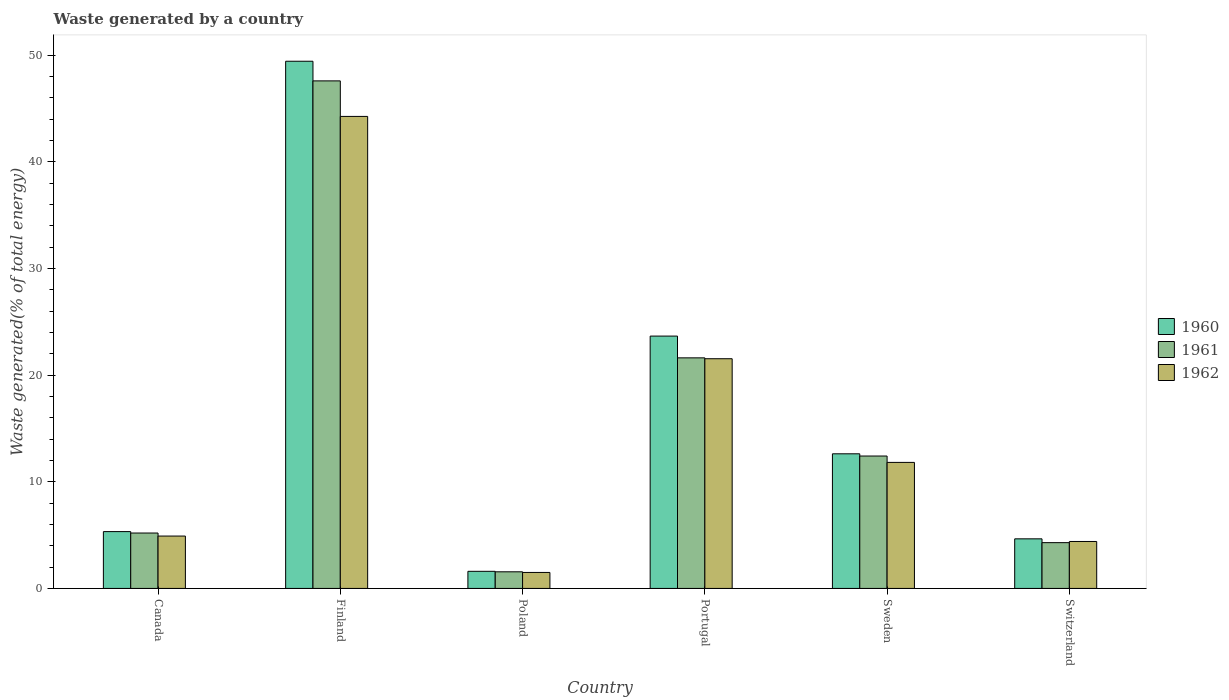How many different coloured bars are there?
Offer a terse response. 3. How many bars are there on the 5th tick from the left?
Your answer should be compact. 3. How many bars are there on the 1st tick from the right?
Keep it short and to the point. 3. What is the label of the 6th group of bars from the left?
Provide a succinct answer. Switzerland. What is the total waste generated in 1960 in Switzerland?
Offer a very short reply. 4.65. Across all countries, what is the maximum total waste generated in 1961?
Provide a short and direct response. 47.58. Across all countries, what is the minimum total waste generated in 1960?
Keep it short and to the point. 1.6. In which country was the total waste generated in 1962 minimum?
Give a very brief answer. Poland. What is the total total waste generated in 1961 in the graph?
Provide a short and direct response. 92.66. What is the difference between the total waste generated in 1961 in Sweden and that in Switzerland?
Your answer should be compact. 8.12. What is the difference between the total waste generated in 1960 in Poland and the total waste generated in 1961 in Canada?
Make the answer very short. -3.59. What is the average total waste generated in 1961 per country?
Your answer should be very brief. 15.44. What is the difference between the total waste generated of/in 1962 and total waste generated of/in 1960 in Switzerland?
Ensure brevity in your answer.  -0.25. In how many countries, is the total waste generated in 1962 greater than 12 %?
Your answer should be very brief. 2. What is the ratio of the total waste generated in 1961 in Canada to that in Finland?
Make the answer very short. 0.11. What is the difference between the highest and the second highest total waste generated in 1960?
Keep it short and to the point. 36.8. What is the difference between the highest and the lowest total waste generated in 1962?
Your answer should be very brief. 42.75. Is the sum of the total waste generated in 1961 in Canada and Portugal greater than the maximum total waste generated in 1960 across all countries?
Your response must be concise. No. How many countries are there in the graph?
Provide a short and direct response. 6. What is the difference between two consecutive major ticks on the Y-axis?
Provide a short and direct response. 10. Are the values on the major ticks of Y-axis written in scientific E-notation?
Provide a short and direct response. No. Does the graph contain grids?
Make the answer very short. No. How many legend labels are there?
Your answer should be very brief. 3. How are the legend labels stacked?
Give a very brief answer. Vertical. What is the title of the graph?
Offer a terse response. Waste generated by a country. Does "2015" appear as one of the legend labels in the graph?
Give a very brief answer. No. What is the label or title of the X-axis?
Make the answer very short. Country. What is the label or title of the Y-axis?
Offer a very short reply. Waste generated(% of total energy). What is the Waste generated(% of total energy) of 1960 in Canada?
Ensure brevity in your answer.  5.33. What is the Waste generated(% of total energy) of 1961 in Canada?
Give a very brief answer. 5.19. What is the Waste generated(% of total energy) in 1962 in Canada?
Your response must be concise. 4.91. What is the Waste generated(% of total energy) of 1960 in Finland?
Your answer should be compact. 49.42. What is the Waste generated(% of total energy) of 1961 in Finland?
Provide a short and direct response. 47.58. What is the Waste generated(% of total energy) of 1962 in Finland?
Your answer should be compact. 44.25. What is the Waste generated(% of total energy) in 1960 in Poland?
Provide a short and direct response. 1.6. What is the Waste generated(% of total energy) of 1961 in Poland?
Make the answer very short. 1.56. What is the Waste generated(% of total energy) of 1962 in Poland?
Make the answer very short. 1.5. What is the Waste generated(% of total energy) in 1960 in Portugal?
Your response must be concise. 23.66. What is the Waste generated(% of total energy) in 1961 in Portugal?
Keep it short and to the point. 21.62. What is the Waste generated(% of total energy) in 1962 in Portugal?
Your response must be concise. 21.53. What is the Waste generated(% of total energy) in 1960 in Sweden?
Your answer should be very brief. 12.62. What is the Waste generated(% of total energy) in 1961 in Sweden?
Offer a terse response. 12.41. What is the Waste generated(% of total energy) in 1962 in Sweden?
Your answer should be very brief. 11.82. What is the Waste generated(% of total energy) in 1960 in Switzerland?
Give a very brief answer. 4.65. What is the Waste generated(% of total energy) of 1961 in Switzerland?
Your answer should be compact. 4.29. What is the Waste generated(% of total energy) in 1962 in Switzerland?
Make the answer very short. 4.4. Across all countries, what is the maximum Waste generated(% of total energy) of 1960?
Your answer should be very brief. 49.42. Across all countries, what is the maximum Waste generated(% of total energy) in 1961?
Offer a very short reply. 47.58. Across all countries, what is the maximum Waste generated(% of total energy) of 1962?
Your response must be concise. 44.25. Across all countries, what is the minimum Waste generated(% of total energy) of 1960?
Offer a very short reply. 1.6. Across all countries, what is the minimum Waste generated(% of total energy) of 1961?
Your response must be concise. 1.56. Across all countries, what is the minimum Waste generated(% of total energy) in 1962?
Offer a terse response. 1.5. What is the total Waste generated(% of total energy) of 1960 in the graph?
Ensure brevity in your answer.  97.28. What is the total Waste generated(% of total energy) of 1961 in the graph?
Offer a very short reply. 92.66. What is the total Waste generated(% of total energy) of 1962 in the graph?
Offer a very short reply. 88.41. What is the difference between the Waste generated(% of total energy) in 1960 in Canada and that in Finland?
Keep it short and to the point. -44.1. What is the difference between the Waste generated(% of total energy) in 1961 in Canada and that in Finland?
Your answer should be very brief. -42.39. What is the difference between the Waste generated(% of total energy) of 1962 in Canada and that in Finland?
Offer a very short reply. -39.34. What is the difference between the Waste generated(% of total energy) of 1960 in Canada and that in Poland?
Give a very brief answer. 3.72. What is the difference between the Waste generated(% of total energy) in 1961 in Canada and that in Poland?
Give a very brief answer. 3.64. What is the difference between the Waste generated(% of total energy) of 1962 in Canada and that in Poland?
Keep it short and to the point. 3.41. What is the difference between the Waste generated(% of total energy) in 1960 in Canada and that in Portugal?
Your answer should be very brief. -18.33. What is the difference between the Waste generated(% of total energy) in 1961 in Canada and that in Portugal?
Provide a short and direct response. -16.42. What is the difference between the Waste generated(% of total energy) of 1962 in Canada and that in Portugal?
Make the answer very short. -16.62. What is the difference between the Waste generated(% of total energy) in 1960 in Canada and that in Sweden?
Your response must be concise. -7.29. What is the difference between the Waste generated(% of total energy) of 1961 in Canada and that in Sweden?
Provide a short and direct response. -7.22. What is the difference between the Waste generated(% of total energy) of 1962 in Canada and that in Sweden?
Make the answer very short. -6.9. What is the difference between the Waste generated(% of total energy) in 1960 in Canada and that in Switzerland?
Provide a short and direct response. 0.68. What is the difference between the Waste generated(% of total energy) of 1961 in Canada and that in Switzerland?
Keep it short and to the point. 0.9. What is the difference between the Waste generated(% of total energy) of 1962 in Canada and that in Switzerland?
Provide a succinct answer. 0.51. What is the difference between the Waste generated(% of total energy) of 1960 in Finland and that in Poland?
Keep it short and to the point. 47.82. What is the difference between the Waste generated(% of total energy) of 1961 in Finland and that in Poland?
Your response must be concise. 46.02. What is the difference between the Waste generated(% of total energy) of 1962 in Finland and that in Poland?
Give a very brief answer. 42.75. What is the difference between the Waste generated(% of total energy) in 1960 in Finland and that in Portugal?
Provide a succinct answer. 25.77. What is the difference between the Waste generated(% of total energy) of 1961 in Finland and that in Portugal?
Ensure brevity in your answer.  25.96. What is the difference between the Waste generated(% of total energy) of 1962 in Finland and that in Portugal?
Keep it short and to the point. 22.72. What is the difference between the Waste generated(% of total energy) in 1960 in Finland and that in Sweden?
Your answer should be compact. 36.8. What is the difference between the Waste generated(% of total energy) in 1961 in Finland and that in Sweden?
Offer a terse response. 35.17. What is the difference between the Waste generated(% of total energy) of 1962 in Finland and that in Sweden?
Keep it short and to the point. 32.44. What is the difference between the Waste generated(% of total energy) of 1960 in Finland and that in Switzerland?
Your answer should be compact. 44.77. What is the difference between the Waste generated(% of total energy) in 1961 in Finland and that in Switzerland?
Keep it short and to the point. 43.29. What is the difference between the Waste generated(% of total energy) in 1962 in Finland and that in Switzerland?
Keep it short and to the point. 39.85. What is the difference between the Waste generated(% of total energy) in 1960 in Poland and that in Portugal?
Your response must be concise. -22.05. What is the difference between the Waste generated(% of total energy) of 1961 in Poland and that in Portugal?
Your answer should be very brief. -20.06. What is the difference between the Waste generated(% of total energy) in 1962 in Poland and that in Portugal?
Provide a succinct answer. -20.03. What is the difference between the Waste generated(% of total energy) in 1960 in Poland and that in Sweden?
Make the answer very short. -11.02. What is the difference between the Waste generated(% of total energy) of 1961 in Poland and that in Sweden?
Your response must be concise. -10.85. What is the difference between the Waste generated(% of total energy) in 1962 in Poland and that in Sweden?
Offer a very short reply. -10.32. What is the difference between the Waste generated(% of total energy) of 1960 in Poland and that in Switzerland?
Your answer should be compact. -3.04. What is the difference between the Waste generated(% of total energy) of 1961 in Poland and that in Switzerland?
Ensure brevity in your answer.  -2.73. What is the difference between the Waste generated(% of total energy) of 1962 in Poland and that in Switzerland?
Your answer should be very brief. -2.9. What is the difference between the Waste generated(% of total energy) of 1960 in Portugal and that in Sweden?
Make the answer very short. 11.03. What is the difference between the Waste generated(% of total energy) in 1961 in Portugal and that in Sweden?
Your response must be concise. 9.2. What is the difference between the Waste generated(% of total energy) of 1962 in Portugal and that in Sweden?
Your answer should be very brief. 9.72. What is the difference between the Waste generated(% of total energy) in 1960 in Portugal and that in Switzerland?
Give a very brief answer. 19.01. What is the difference between the Waste generated(% of total energy) of 1961 in Portugal and that in Switzerland?
Provide a succinct answer. 17.32. What is the difference between the Waste generated(% of total energy) in 1962 in Portugal and that in Switzerland?
Ensure brevity in your answer.  17.13. What is the difference between the Waste generated(% of total energy) in 1960 in Sweden and that in Switzerland?
Ensure brevity in your answer.  7.97. What is the difference between the Waste generated(% of total energy) in 1961 in Sweden and that in Switzerland?
Provide a short and direct response. 8.12. What is the difference between the Waste generated(% of total energy) of 1962 in Sweden and that in Switzerland?
Ensure brevity in your answer.  7.41. What is the difference between the Waste generated(% of total energy) in 1960 in Canada and the Waste generated(% of total energy) in 1961 in Finland?
Provide a short and direct response. -42.25. What is the difference between the Waste generated(% of total energy) in 1960 in Canada and the Waste generated(% of total energy) in 1962 in Finland?
Make the answer very short. -38.92. What is the difference between the Waste generated(% of total energy) of 1961 in Canada and the Waste generated(% of total energy) of 1962 in Finland?
Keep it short and to the point. -39.06. What is the difference between the Waste generated(% of total energy) in 1960 in Canada and the Waste generated(% of total energy) in 1961 in Poland?
Ensure brevity in your answer.  3.77. What is the difference between the Waste generated(% of total energy) of 1960 in Canada and the Waste generated(% of total energy) of 1962 in Poland?
Your response must be concise. 3.83. What is the difference between the Waste generated(% of total energy) of 1961 in Canada and the Waste generated(% of total energy) of 1962 in Poland?
Provide a succinct answer. 3.7. What is the difference between the Waste generated(% of total energy) of 1960 in Canada and the Waste generated(% of total energy) of 1961 in Portugal?
Your answer should be compact. -16.29. What is the difference between the Waste generated(% of total energy) in 1960 in Canada and the Waste generated(% of total energy) in 1962 in Portugal?
Offer a very short reply. -16.21. What is the difference between the Waste generated(% of total energy) of 1961 in Canada and the Waste generated(% of total energy) of 1962 in Portugal?
Ensure brevity in your answer.  -16.34. What is the difference between the Waste generated(% of total energy) of 1960 in Canada and the Waste generated(% of total energy) of 1961 in Sweden?
Give a very brief answer. -7.08. What is the difference between the Waste generated(% of total energy) in 1960 in Canada and the Waste generated(% of total energy) in 1962 in Sweden?
Your response must be concise. -6.49. What is the difference between the Waste generated(% of total energy) in 1961 in Canada and the Waste generated(% of total energy) in 1962 in Sweden?
Your response must be concise. -6.62. What is the difference between the Waste generated(% of total energy) of 1960 in Canada and the Waste generated(% of total energy) of 1961 in Switzerland?
Ensure brevity in your answer.  1.04. What is the difference between the Waste generated(% of total energy) of 1960 in Canada and the Waste generated(% of total energy) of 1962 in Switzerland?
Make the answer very short. 0.93. What is the difference between the Waste generated(% of total energy) of 1961 in Canada and the Waste generated(% of total energy) of 1962 in Switzerland?
Provide a short and direct response. 0.79. What is the difference between the Waste generated(% of total energy) of 1960 in Finland and the Waste generated(% of total energy) of 1961 in Poland?
Offer a terse response. 47.86. What is the difference between the Waste generated(% of total energy) of 1960 in Finland and the Waste generated(% of total energy) of 1962 in Poland?
Offer a very short reply. 47.92. What is the difference between the Waste generated(% of total energy) in 1961 in Finland and the Waste generated(% of total energy) in 1962 in Poland?
Offer a terse response. 46.08. What is the difference between the Waste generated(% of total energy) in 1960 in Finland and the Waste generated(% of total energy) in 1961 in Portugal?
Your answer should be very brief. 27.81. What is the difference between the Waste generated(% of total energy) in 1960 in Finland and the Waste generated(% of total energy) in 1962 in Portugal?
Ensure brevity in your answer.  27.89. What is the difference between the Waste generated(% of total energy) in 1961 in Finland and the Waste generated(% of total energy) in 1962 in Portugal?
Your response must be concise. 26.05. What is the difference between the Waste generated(% of total energy) of 1960 in Finland and the Waste generated(% of total energy) of 1961 in Sweden?
Make the answer very short. 37.01. What is the difference between the Waste generated(% of total energy) in 1960 in Finland and the Waste generated(% of total energy) in 1962 in Sweden?
Your response must be concise. 37.61. What is the difference between the Waste generated(% of total energy) in 1961 in Finland and the Waste generated(% of total energy) in 1962 in Sweden?
Make the answer very short. 35.77. What is the difference between the Waste generated(% of total energy) of 1960 in Finland and the Waste generated(% of total energy) of 1961 in Switzerland?
Your answer should be compact. 45.13. What is the difference between the Waste generated(% of total energy) of 1960 in Finland and the Waste generated(% of total energy) of 1962 in Switzerland?
Your answer should be compact. 45.02. What is the difference between the Waste generated(% of total energy) of 1961 in Finland and the Waste generated(% of total energy) of 1962 in Switzerland?
Offer a very short reply. 43.18. What is the difference between the Waste generated(% of total energy) in 1960 in Poland and the Waste generated(% of total energy) in 1961 in Portugal?
Your response must be concise. -20.01. What is the difference between the Waste generated(% of total energy) of 1960 in Poland and the Waste generated(% of total energy) of 1962 in Portugal?
Offer a terse response. -19.93. What is the difference between the Waste generated(% of total energy) of 1961 in Poland and the Waste generated(% of total energy) of 1962 in Portugal?
Ensure brevity in your answer.  -19.98. What is the difference between the Waste generated(% of total energy) in 1960 in Poland and the Waste generated(% of total energy) in 1961 in Sweden?
Keep it short and to the point. -10.81. What is the difference between the Waste generated(% of total energy) of 1960 in Poland and the Waste generated(% of total energy) of 1962 in Sweden?
Your answer should be very brief. -10.21. What is the difference between the Waste generated(% of total energy) in 1961 in Poland and the Waste generated(% of total energy) in 1962 in Sweden?
Your answer should be compact. -10.26. What is the difference between the Waste generated(% of total energy) in 1960 in Poland and the Waste generated(% of total energy) in 1961 in Switzerland?
Keep it short and to the point. -2.69. What is the difference between the Waste generated(% of total energy) in 1960 in Poland and the Waste generated(% of total energy) in 1962 in Switzerland?
Offer a very short reply. -2.8. What is the difference between the Waste generated(% of total energy) in 1961 in Poland and the Waste generated(% of total energy) in 1962 in Switzerland?
Provide a short and direct response. -2.84. What is the difference between the Waste generated(% of total energy) of 1960 in Portugal and the Waste generated(% of total energy) of 1961 in Sweden?
Give a very brief answer. 11.24. What is the difference between the Waste generated(% of total energy) of 1960 in Portugal and the Waste generated(% of total energy) of 1962 in Sweden?
Offer a terse response. 11.84. What is the difference between the Waste generated(% of total energy) in 1961 in Portugal and the Waste generated(% of total energy) in 1962 in Sweden?
Offer a terse response. 9.8. What is the difference between the Waste generated(% of total energy) in 1960 in Portugal and the Waste generated(% of total energy) in 1961 in Switzerland?
Provide a short and direct response. 19.36. What is the difference between the Waste generated(% of total energy) in 1960 in Portugal and the Waste generated(% of total energy) in 1962 in Switzerland?
Ensure brevity in your answer.  19.25. What is the difference between the Waste generated(% of total energy) of 1961 in Portugal and the Waste generated(% of total energy) of 1962 in Switzerland?
Give a very brief answer. 17.21. What is the difference between the Waste generated(% of total energy) of 1960 in Sweden and the Waste generated(% of total energy) of 1961 in Switzerland?
Keep it short and to the point. 8.33. What is the difference between the Waste generated(% of total energy) of 1960 in Sweden and the Waste generated(% of total energy) of 1962 in Switzerland?
Your response must be concise. 8.22. What is the difference between the Waste generated(% of total energy) in 1961 in Sweden and the Waste generated(% of total energy) in 1962 in Switzerland?
Ensure brevity in your answer.  8.01. What is the average Waste generated(% of total energy) of 1960 per country?
Give a very brief answer. 16.21. What is the average Waste generated(% of total energy) of 1961 per country?
Provide a succinct answer. 15.44. What is the average Waste generated(% of total energy) in 1962 per country?
Make the answer very short. 14.74. What is the difference between the Waste generated(% of total energy) of 1960 and Waste generated(% of total energy) of 1961 in Canada?
Provide a short and direct response. 0.13. What is the difference between the Waste generated(% of total energy) in 1960 and Waste generated(% of total energy) in 1962 in Canada?
Make the answer very short. 0.42. What is the difference between the Waste generated(% of total energy) of 1961 and Waste generated(% of total energy) of 1962 in Canada?
Give a very brief answer. 0.28. What is the difference between the Waste generated(% of total energy) in 1960 and Waste generated(% of total energy) in 1961 in Finland?
Your answer should be compact. 1.84. What is the difference between the Waste generated(% of total energy) of 1960 and Waste generated(% of total energy) of 1962 in Finland?
Offer a terse response. 5.17. What is the difference between the Waste generated(% of total energy) of 1961 and Waste generated(% of total energy) of 1962 in Finland?
Your answer should be very brief. 3.33. What is the difference between the Waste generated(% of total energy) in 1960 and Waste generated(% of total energy) in 1961 in Poland?
Ensure brevity in your answer.  0.05. What is the difference between the Waste generated(% of total energy) of 1960 and Waste generated(% of total energy) of 1962 in Poland?
Offer a very short reply. 0.11. What is the difference between the Waste generated(% of total energy) in 1961 and Waste generated(% of total energy) in 1962 in Poland?
Make the answer very short. 0.06. What is the difference between the Waste generated(% of total energy) in 1960 and Waste generated(% of total energy) in 1961 in Portugal?
Your response must be concise. 2.04. What is the difference between the Waste generated(% of total energy) of 1960 and Waste generated(% of total energy) of 1962 in Portugal?
Keep it short and to the point. 2.12. What is the difference between the Waste generated(% of total energy) of 1961 and Waste generated(% of total energy) of 1962 in Portugal?
Your response must be concise. 0.08. What is the difference between the Waste generated(% of total energy) of 1960 and Waste generated(% of total energy) of 1961 in Sweden?
Give a very brief answer. 0.21. What is the difference between the Waste generated(% of total energy) in 1960 and Waste generated(% of total energy) in 1962 in Sweden?
Keep it short and to the point. 0.81. What is the difference between the Waste generated(% of total energy) of 1961 and Waste generated(% of total energy) of 1962 in Sweden?
Your response must be concise. 0.6. What is the difference between the Waste generated(% of total energy) in 1960 and Waste generated(% of total energy) in 1961 in Switzerland?
Offer a very short reply. 0.36. What is the difference between the Waste generated(% of total energy) of 1960 and Waste generated(% of total energy) of 1962 in Switzerland?
Offer a terse response. 0.25. What is the difference between the Waste generated(% of total energy) of 1961 and Waste generated(% of total energy) of 1962 in Switzerland?
Offer a terse response. -0.11. What is the ratio of the Waste generated(% of total energy) of 1960 in Canada to that in Finland?
Provide a short and direct response. 0.11. What is the ratio of the Waste generated(% of total energy) in 1961 in Canada to that in Finland?
Your response must be concise. 0.11. What is the ratio of the Waste generated(% of total energy) of 1962 in Canada to that in Finland?
Your response must be concise. 0.11. What is the ratio of the Waste generated(% of total energy) of 1960 in Canada to that in Poland?
Your answer should be very brief. 3.32. What is the ratio of the Waste generated(% of total energy) of 1961 in Canada to that in Poland?
Give a very brief answer. 3.33. What is the ratio of the Waste generated(% of total energy) of 1962 in Canada to that in Poland?
Make the answer very short. 3.28. What is the ratio of the Waste generated(% of total energy) in 1960 in Canada to that in Portugal?
Keep it short and to the point. 0.23. What is the ratio of the Waste generated(% of total energy) in 1961 in Canada to that in Portugal?
Give a very brief answer. 0.24. What is the ratio of the Waste generated(% of total energy) of 1962 in Canada to that in Portugal?
Offer a terse response. 0.23. What is the ratio of the Waste generated(% of total energy) of 1960 in Canada to that in Sweden?
Ensure brevity in your answer.  0.42. What is the ratio of the Waste generated(% of total energy) of 1961 in Canada to that in Sweden?
Offer a very short reply. 0.42. What is the ratio of the Waste generated(% of total energy) in 1962 in Canada to that in Sweden?
Your answer should be very brief. 0.42. What is the ratio of the Waste generated(% of total energy) of 1960 in Canada to that in Switzerland?
Provide a succinct answer. 1.15. What is the ratio of the Waste generated(% of total energy) of 1961 in Canada to that in Switzerland?
Provide a short and direct response. 1.21. What is the ratio of the Waste generated(% of total energy) in 1962 in Canada to that in Switzerland?
Ensure brevity in your answer.  1.12. What is the ratio of the Waste generated(% of total energy) of 1960 in Finland to that in Poland?
Keep it short and to the point. 30.8. What is the ratio of the Waste generated(% of total energy) of 1961 in Finland to that in Poland?
Keep it short and to the point. 30.53. What is the ratio of the Waste generated(% of total energy) in 1962 in Finland to that in Poland?
Provide a succinct answer. 29.52. What is the ratio of the Waste generated(% of total energy) of 1960 in Finland to that in Portugal?
Ensure brevity in your answer.  2.09. What is the ratio of the Waste generated(% of total energy) in 1961 in Finland to that in Portugal?
Your answer should be compact. 2.2. What is the ratio of the Waste generated(% of total energy) of 1962 in Finland to that in Portugal?
Make the answer very short. 2.05. What is the ratio of the Waste generated(% of total energy) in 1960 in Finland to that in Sweden?
Make the answer very short. 3.92. What is the ratio of the Waste generated(% of total energy) of 1961 in Finland to that in Sweden?
Offer a very short reply. 3.83. What is the ratio of the Waste generated(% of total energy) of 1962 in Finland to that in Sweden?
Give a very brief answer. 3.75. What is the ratio of the Waste generated(% of total energy) in 1960 in Finland to that in Switzerland?
Offer a terse response. 10.63. What is the ratio of the Waste generated(% of total energy) in 1961 in Finland to that in Switzerland?
Give a very brief answer. 11.09. What is the ratio of the Waste generated(% of total energy) in 1962 in Finland to that in Switzerland?
Give a very brief answer. 10.05. What is the ratio of the Waste generated(% of total energy) of 1960 in Poland to that in Portugal?
Your answer should be very brief. 0.07. What is the ratio of the Waste generated(% of total energy) in 1961 in Poland to that in Portugal?
Provide a short and direct response. 0.07. What is the ratio of the Waste generated(% of total energy) in 1962 in Poland to that in Portugal?
Your response must be concise. 0.07. What is the ratio of the Waste generated(% of total energy) in 1960 in Poland to that in Sweden?
Provide a short and direct response. 0.13. What is the ratio of the Waste generated(% of total energy) of 1961 in Poland to that in Sweden?
Give a very brief answer. 0.13. What is the ratio of the Waste generated(% of total energy) in 1962 in Poland to that in Sweden?
Make the answer very short. 0.13. What is the ratio of the Waste generated(% of total energy) of 1960 in Poland to that in Switzerland?
Provide a short and direct response. 0.35. What is the ratio of the Waste generated(% of total energy) of 1961 in Poland to that in Switzerland?
Your answer should be very brief. 0.36. What is the ratio of the Waste generated(% of total energy) of 1962 in Poland to that in Switzerland?
Your response must be concise. 0.34. What is the ratio of the Waste generated(% of total energy) in 1960 in Portugal to that in Sweden?
Your response must be concise. 1.87. What is the ratio of the Waste generated(% of total energy) in 1961 in Portugal to that in Sweden?
Give a very brief answer. 1.74. What is the ratio of the Waste generated(% of total energy) of 1962 in Portugal to that in Sweden?
Your answer should be very brief. 1.82. What is the ratio of the Waste generated(% of total energy) of 1960 in Portugal to that in Switzerland?
Your response must be concise. 5.09. What is the ratio of the Waste generated(% of total energy) in 1961 in Portugal to that in Switzerland?
Ensure brevity in your answer.  5.04. What is the ratio of the Waste generated(% of total energy) of 1962 in Portugal to that in Switzerland?
Keep it short and to the point. 4.89. What is the ratio of the Waste generated(% of total energy) in 1960 in Sweden to that in Switzerland?
Ensure brevity in your answer.  2.71. What is the ratio of the Waste generated(% of total energy) of 1961 in Sweden to that in Switzerland?
Keep it short and to the point. 2.89. What is the ratio of the Waste generated(% of total energy) of 1962 in Sweden to that in Switzerland?
Offer a very short reply. 2.68. What is the difference between the highest and the second highest Waste generated(% of total energy) in 1960?
Offer a terse response. 25.77. What is the difference between the highest and the second highest Waste generated(% of total energy) of 1961?
Keep it short and to the point. 25.96. What is the difference between the highest and the second highest Waste generated(% of total energy) of 1962?
Your response must be concise. 22.72. What is the difference between the highest and the lowest Waste generated(% of total energy) of 1960?
Give a very brief answer. 47.82. What is the difference between the highest and the lowest Waste generated(% of total energy) in 1961?
Ensure brevity in your answer.  46.02. What is the difference between the highest and the lowest Waste generated(% of total energy) of 1962?
Offer a terse response. 42.75. 